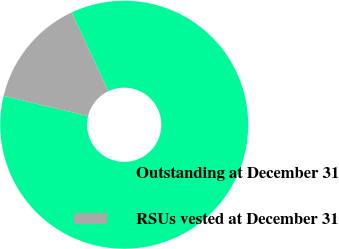<chart> <loc_0><loc_0><loc_500><loc_500><pie_chart><fcel>Outstanding at December 31<fcel>RSUs vested at December 31<nl><fcel>85.71%<fcel>14.29%<nl></chart> 